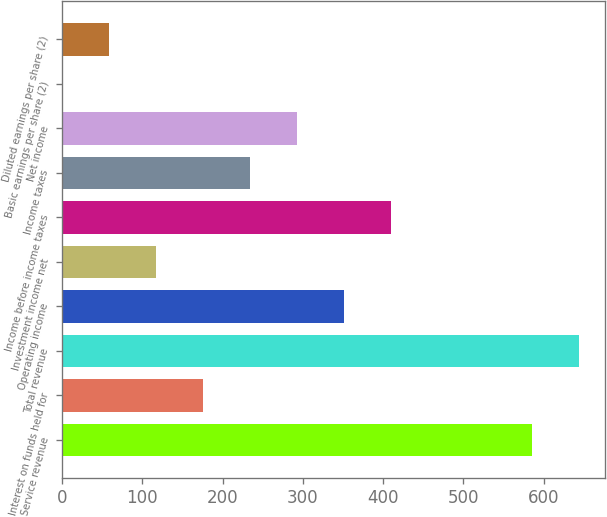<chart> <loc_0><loc_0><loc_500><loc_500><bar_chart><fcel>Service revenue<fcel>Interest on funds held for<fcel>Total revenue<fcel>Operating income<fcel>Investment income net<fcel>Income before income taxes<fcel>Income taxes<fcel>Net income<fcel>Basic earnings per share (2)<fcel>Diluted earnings per share (2)<nl><fcel>585.34<fcel>175.84<fcel>643.84<fcel>351.34<fcel>117.34<fcel>409.84<fcel>234.34<fcel>292.84<fcel>0.34<fcel>58.84<nl></chart> 